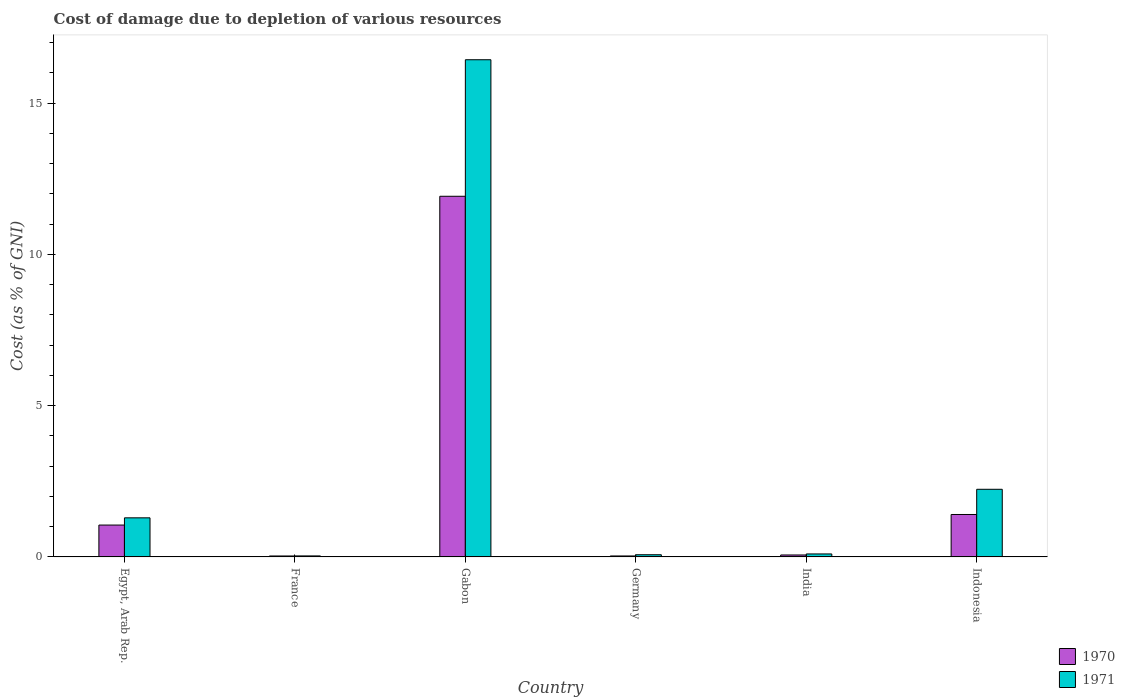Are the number of bars per tick equal to the number of legend labels?
Provide a succinct answer. Yes. Are the number of bars on each tick of the X-axis equal?
Provide a short and direct response. Yes. How many bars are there on the 2nd tick from the left?
Provide a short and direct response. 2. What is the label of the 3rd group of bars from the left?
Your answer should be compact. Gabon. What is the cost of damage caused due to the depletion of various resources in 1970 in Indonesia?
Your response must be concise. 1.4. Across all countries, what is the maximum cost of damage caused due to the depletion of various resources in 1970?
Your answer should be compact. 11.92. Across all countries, what is the minimum cost of damage caused due to the depletion of various resources in 1971?
Your answer should be very brief. 0.03. In which country was the cost of damage caused due to the depletion of various resources in 1970 maximum?
Provide a succinct answer. Gabon. What is the total cost of damage caused due to the depletion of various resources in 1970 in the graph?
Keep it short and to the point. 14.5. What is the difference between the cost of damage caused due to the depletion of various resources in 1970 in Egypt, Arab Rep. and that in Indonesia?
Your response must be concise. -0.35. What is the difference between the cost of damage caused due to the depletion of various resources in 1970 in India and the cost of damage caused due to the depletion of various resources in 1971 in Egypt, Arab Rep.?
Offer a terse response. -1.23. What is the average cost of damage caused due to the depletion of various resources in 1971 per country?
Make the answer very short. 3.36. What is the difference between the cost of damage caused due to the depletion of various resources of/in 1971 and cost of damage caused due to the depletion of various resources of/in 1970 in France?
Provide a succinct answer. 0. In how many countries, is the cost of damage caused due to the depletion of various resources in 1971 greater than 15 %?
Offer a very short reply. 1. What is the ratio of the cost of damage caused due to the depletion of various resources in 1970 in Egypt, Arab Rep. to that in India?
Provide a short and direct response. 16.34. What is the difference between the highest and the second highest cost of damage caused due to the depletion of various resources in 1970?
Provide a succinct answer. -10.52. What is the difference between the highest and the lowest cost of damage caused due to the depletion of various resources in 1970?
Provide a short and direct response. 11.89. Is the sum of the cost of damage caused due to the depletion of various resources in 1970 in Egypt, Arab Rep. and India greater than the maximum cost of damage caused due to the depletion of various resources in 1971 across all countries?
Your answer should be compact. No. What does the 2nd bar from the left in Egypt, Arab Rep. represents?
Make the answer very short. 1971. Are all the bars in the graph horizontal?
Offer a terse response. No. What is the difference between two consecutive major ticks on the Y-axis?
Your answer should be compact. 5. Are the values on the major ticks of Y-axis written in scientific E-notation?
Ensure brevity in your answer.  No. Does the graph contain grids?
Provide a succinct answer. No. How many legend labels are there?
Keep it short and to the point. 2. How are the legend labels stacked?
Give a very brief answer. Vertical. What is the title of the graph?
Ensure brevity in your answer.  Cost of damage due to depletion of various resources. Does "1964" appear as one of the legend labels in the graph?
Your answer should be very brief. No. What is the label or title of the X-axis?
Provide a succinct answer. Country. What is the label or title of the Y-axis?
Your answer should be very brief. Cost (as % of GNI). What is the Cost (as % of GNI) in 1970 in Egypt, Arab Rep.?
Provide a succinct answer. 1.05. What is the Cost (as % of GNI) of 1971 in Egypt, Arab Rep.?
Your answer should be very brief. 1.29. What is the Cost (as % of GNI) in 1970 in France?
Provide a short and direct response. 0.03. What is the Cost (as % of GNI) in 1971 in France?
Your answer should be compact. 0.03. What is the Cost (as % of GNI) in 1970 in Gabon?
Your answer should be very brief. 11.92. What is the Cost (as % of GNI) in 1971 in Gabon?
Keep it short and to the point. 16.43. What is the Cost (as % of GNI) in 1970 in Germany?
Your response must be concise. 0.03. What is the Cost (as % of GNI) in 1971 in Germany?
Provide a short and direct response. 0.07. What is the Cost (as % of GNI) of 1970 in India?
Offer a terse response. 0.06. What is the Cost (as % of GNI) in 1971 in India?
Your answer should be very brief. 0.1. What is the Cost (as % of GNI) in 1970 in Indonesia?
Your answer should be very brief. 1.4. What is the Cost (as % of GNI) of 1971 in Indonesia?
Keep it short and to the point. 2.24. Across all countries, what is the maximum Cost (as % of GNI) in 1970?
Ensure brevity in your answer.  11.92. Across all countries, what is the maximum Cost (as % of GNI) of 1971?
Provide a succinct answer. 16.43. Across all countries, what is the minimum Cost (as % of GNI) of 1970?
Provide a short and direct response. 0.03. Across all countries, what is the minimum Cost (as % of GNI) of 1971?
Ensure brevity in your answer.  0.03. What is the total Cost (as % of GNI) in 1970 in the graph?
Your response must be concise. 14.5. What is the total Cost (as % of GNI) of 1971 in the graph?
Provide a short and direct response. 20.16. What is the difference between the Cost (as % of GNI) in 1970 in Egypt, Arab Rep. and that in France?
Your answer should be compact. 1.02. What is the difference between the Cost (as % of GNI) in 1971 in Egypt, Arab Rep. and that in France?
Offer a terse response. 1.26. What is the difference between the Cost (as % of GNI) in 1970 in Egypt, Arab Rep. and that in Gabon?
Your response must be concise. -10.87. What is the difference between the Cost (as % of GNI) of 1971 in Egypt, Arab Rep. and that in Gabon?
Give a very brief answer. -15.14. What is the difference between the Cost (as % of GNI) in 1970 in Egypt, Arab Rep. and that in Germany?
Keep it short and to the point. 1.02. What is the difference between the Cost (as % of GNI) in 1971 in Egypt, Arab Rep. and that in Germany?
Offer a very short reply. 1.22. What is the difference between the Cost (as % of GNI) of 1970 in Egypt, Arab Rep. and that in India?
Offer a terse response. 0.99. What is the difference between the Cost (as % of GNI) of 1971 in Egypt, Arab Rep. and that in India?
Your response must be concise. 1.19. What is the difference between the Cost (as % of GNI) of 1970 in Egypt, Arab Rep. and that in Indonesia?
Provide a succinct answer. -0.35. What is the difference between the Cost (as % of GNI) of 1971 in Egypt, Arab Rep. and that in Indonesia?
Offer a terse response. -0.94. What is the difference between the Cost (as % of GNI) in 1970 in France and that in Gabon?
Keep it short and to the point. -11.89. What is the difference between the Cost (as % of GNI) in 1971 in France and that in Gabon?
Provide a succinct answer. -16.4. What is the difference between the Cost (as % of GNI) in 1970 in France and that in Germany?
Your answer should be very brief. -0. What is the difference between the Cost (as % of GNI) of 1971 in France and that in Germany?
Provide a short and direct response. -0.04. What is the difference between the Cost (as % of GNI) in 1970 in France and that in India?
Your response must be concise. -0.03. What is the difference between the Cost (as % of GNI) in 1971 in France and that in India?
Your response must be concise. -0.07. What is the difference between the Cost (as % of GNI) in 1970 in France and that in Indonesia?
Offer a terse response. -1.37. What is the difference between the Cost (as % of GNI) in 1971 in France and that in Indonesia?
Your answer should be very brief. -2.2. What is the difference between the Cost (as % of GNI) in 1970 in Gabon and that in Germany?
Ensure brevity in your answer.  11.89. What is the difference between the Cost (as % of GNI) in 1971 in Gabon and that in Germany?
Ensure brevity in your answer.  16.36. What is the difference between the Cost (as % of GNI) of 1970 in Gabon and that in India?
Ensure brevity in your answer.  11.86. What is the difference between the Cost (as % of GNI) of 1971 in Gabon and that in India?
Keep it short and to the point. 16.33. What is the difference between the Cost (as % of GNI) of 1970 in Gabon and that in Indonesia?
Your answer should be compact. 10.52. What is the difference between the Cost (as % of GNI) in 1971 in Gabon and that in Indonesia?
Ensure brevity in your answer.  14.2. What is the difference between the Cost (as % of GNI) in 1970 in Germany and that in India?
Offer a very short reply. -0.03. What is the difference between the Cost (as % of GNI) of 1971 in Germany and that in India?
Keep it short and to the point. -0.03. What is the difference between the Cost (as % of GNI) in 1970 in Germany and that in Indonesia?
Provide a succinct answer. -1.37. What is the difference between the Cost (as % of GNI) in 1971 in Germany and that in Indonesia?
Ensure brevity in your answer.  -2.16. What is the difference between the Cost (as % of GNI) of 1970 in India and that in Indonesia?
Your answer should be compact. -1.34. What is the difference between the Cost (as % of GNI) of 1971 in India and that in Indonesia?
Give a very brief answer. -2.14. What is the difference between the Cost (as % of GNI) in 1970 in Egypt, Arab Rep. and the Cost (as % of GNI) in 1971 in France?
Your answer should be compact. 1.02. What is the difference between the Cost (as % of GNI) of 1970 in Egypt, Arab Rep. and the Cost (as % of GNI) of 1971 in Gabon?
Your answer should be very brief. -15.38. What is the difference between the Cost (as % of GNI) of 1970 in Egypt, Arab Rep. and the Cost (as % of GNI) of 1971 in Germany?
Offer a very short reply. 0.98. What is the difference between the Cost (as % of GNI) of 1970 in Egypt, Arab Rep. and the Cost (as % of GNI) of 1971 in India?
Make the answer very short. 0.95. What is the difference between the Cost (as % of GNI) in 1970 in Egypt, Arab Rep. and the Cost (as % of GNI) in 1971 in Indonesia?
Give a very brief answer. -1.18. What is the difference between the Cost (as % of GNI) in 1970 in France and the Cost (as % of GNI) in 1971 in Gabon?
Keep it short and to the point. -16.4. What is the difference between the Cost (as % of GNI) in 1970 in France and the Cost (as % of GNI) in 1971 in Germany?
Offer a terse response. -0.04. What is the difference between the Cost (as % of GNI) of 1970 in France and the Cost (as % of GNI) of 1971 in India?
Offer a terse response. -0.07. What is the difference between the Cost (as % of GNI) of 1970 in France and the Cost (as % of GNI) of 1971 in Indonesia?
Keep it short and to the point. -2.2. What is the difference between the Cost (as % of GNI) of 1970 in Gabon and the Cost (as % of GNI) of 1971 in Germany?
Keep it short and to the point. 11.85. What is the difference between the Cost (as % of GNI) in 1970 in Gabon and the Cost (as % of GNI) in 1971 in India?
Your answer should be compact. 11.82. What is the difference between the Cost (as % of GNI) in 1970 in Gabon and the Cost (as % of GNI) in 1971 in Indonesia?
Offer a terse response. 9.68. What is the difference between the Cost (as % of GNI) in 1970 in Germany and the Cost (as % of GNI) in 1971 in India?
Make the answer very short. -0.07. What is the difference between the Cost (as % of GNI) in 1970 in Germany and the Cost (as % of GNI) in 1971 in Indonesia?
Provide a succinct answer. -2.2. What is the difference between the Cost (as % of GNI) of 1970 in India and the Cost (as % of GNI) of 1971 in Indonesia?
Your answer should be very brief. -2.17. What is the average Cost (as % of GNI) in 1970 per country?
Make the answer very short. 2.42. What is the average Cost (as % of GNI) of 1971 per country?
Your answer should be compact. 3.36. What is the difference between the Cost (as % of GNI) in 1970 and Cost (as % of GNI) in 1971 in Egypt, Arab Rep.?
Offer a very short reply. -0.24. What is the difference between the Cost (as % of GNI) in 1970 and Cost (as % of GNI) in 1971 in France?
Provide a short and direct response. -0. What is the difference between the Cost (as % of GNI) in 1970 and Cost (as % of GNI) in 1971 in Gabon?
Your answer should be compact. -4.51. What is the difference between the Cost (as % of GNI) of 1970 and Cost (as % of GNI) of 1971 in Germany?
Your answer should be compact. -0.04. What is the difference between the Cost (as % of GNI) in 1970 and Cost (as % of GNI) in 1971 in India?
Provide a short and direct response. -0.03. What is the difference between the Cost (as % of GNI) in 1970 and Cost (as % of GNI) in 1971 in Indonesia?
Make the answer very short. -0.83. What is the ratio of the Cost (as % of GNI) in 1970 in Egypt, Arab Rep. to that in France?
Keep it short and to the point. 33.37. What is the ratio of the Cost (as % of GNI) in 1971 in Egypt, Arab Rep. to that in France?
Ensure brevity in your answer.  38.77. What is the ratio of the Cost (as % of GNI) of 1970 in Egypt, Arab Rep. to that in Gabon?
Your answer should be very brief. 0.09. What is the ratio of the Cost (as % of GNI) in 1971 in Egypt, Arab Rep. to that in Gabon?
Your answer should be compact. 0.08. What is the ratio of the Cost (as % of GNI) of 1970 in Egypt, Arab Rep. to that in Germany?
Make the answer very short. 32.93. What is the ratio of the Cost (as % of GNI) of 1971 in Egypt, Arab Rep. to that in Germany?
Give a very brief answer. 17.84. What is the ratio of the Cost (as % of GNI) in 1970 in Egypt, Arab Rep. to that in India?
Offer a terse response. 16.34. What is the ratio of the Cost (as % of GNI) of 1971 in Egypt, Arab Rep. to that in India?
Your answer should be very brief. 13.1. What is the ratio of the Cost (as % of GNI) of 1970 in Egypt, Arab Rep. to that in Indonesia?
Give a very brief answer. 0.75. What is the ratio of the Cost (as % of GNI) of 1971 in Egypt, Arab Rep. to that in Indonesia?
Offer a very short reply. 0.58. What is the ratio of the Cost (as % of GNI) of 1970 in France to that in Gabon?
Make the answer very short. 0. What is the ratio of the Cost (as % of GNI) in 1971 in France to that in Gabon?
Provide a succinct answer. 0. What is the ratio of the Cost (as % of GNI) of 1970 in France to that in Germany?
Offer a very short reply. 0.99. What is the ratio of the Cost (as % of GNI) in 1971 in France to that in Germany?
Make the answer very short. 0.46. What is the ratio of the Cost (as % of GNI) of 1970 in France to that in India?
Offer a terse response. 0.49. What is the ratio of the Cost (as % of GNI) in 1971 in France to that in India?
Provide a short and direct response. 0.34. What is the ratio of the Cost (as % of GNI) of 1970 in France to that in Indonesia?
Your answer should be very brief. 0.02. What is the ratio of the Cost (as % of GNI) of 1971 in France to that in Indonesia?
Offer a very short reply. 0.01. What is the ratio of the Cost (as % of GNI) in 1970 in Gabon to that in Germany?
Your answer should be compact. 372.66. What is the ratio of the Cost (as % of GNI) in 1971 in Gabon to that in Germany?
Offer a very short reply. 226.83. What is the ratio of the Cost (as % of GNI) of 1970 in Gabon to that in India?
Your response must be concise. 184.89. What is the ratio of the Cost (as % of GNI) of 1971 in Gabon to that in India?
Your response must be concise. 166.63. What is the ratio of the Cost (as % of GNI) of 1970 in Gabon to that in Indonesia?
Offer a very short reply. 8.5. What is the ratio of the Cost (as % of GNI) of 1971 in Gabon to that in Indonesia?
Provide a short and direct response. 7.35. What is the ratio of the Cost (as % of GNI) of 1970 in Germany to that in India?
Your answer should be very brief. 0.5. What is the ratio of the Cost (as % of GNI) of 1971 in Germany to that in India?
Your response must be concise. 0.73. What is the ratio of the Cost (as % of GNI) of 1970 in Germany to that in Indonesia?
Keep it short and to the point. 0.02. What is the ratio of the Cost (as % of GNI) in 1971 in Germany to that in Indonesia?
Provide a succinct answer. 0.03. What is the ratio of the Cost (as % of GNI) in 1970 in India to that in Indonesia?
Your answer should be compact. 0.05. What is the ratio of the Cost (as % of GNI) of 1971 in India to that in Indonesia?
Offer a very short reply. 0.04. What is the difference between the highest and the second highest Cost (as % of GNI) of 1970?
Provide a succinct answer. 10.52. What is the difference between the highest and the second highest Cost (as % of GNI) in 1971?
Provide a succinct answer. 14.2. What is the difference between the highest and the lowest Cost (as % of GNI) of 1970?
Your response must be concise. 11.89. What is the difference between the highest and the lowest Cost (as % of GNI) of 1971?
Offer a very short reply. 16.4. 